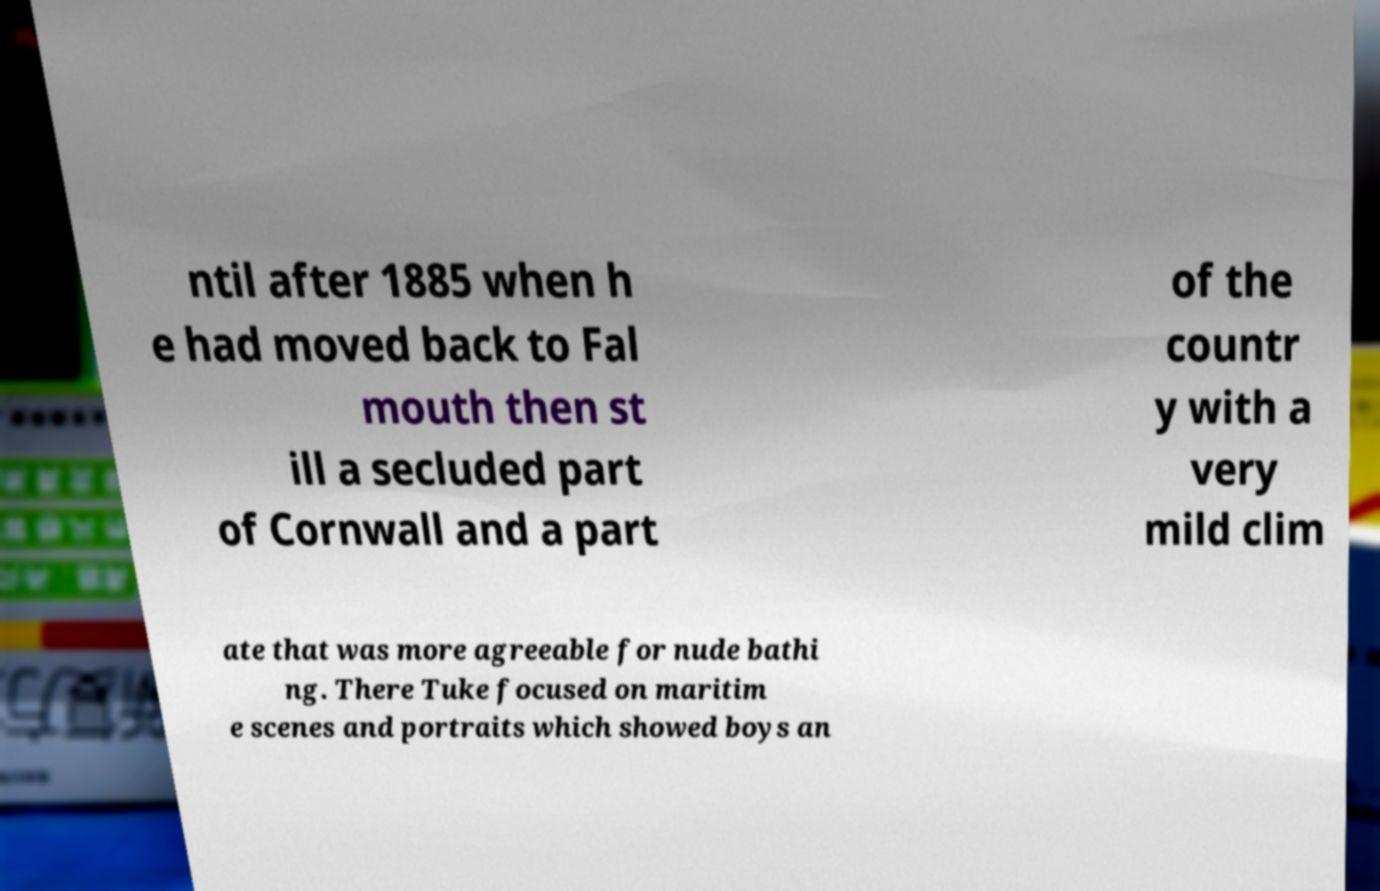Can you read and provide the text displayed in the image?This photo seems to have some interesting text. Can you extract and type it out for me? ntil after 1885 when h e had moved back to Fal mouth then st ill a secluded part of Cornwall and a part of the countr y with a very mild clim ate that was more agreeable for nude bathi ng. There Tuke focused on maritim e scenes and portraits which showed boys an 